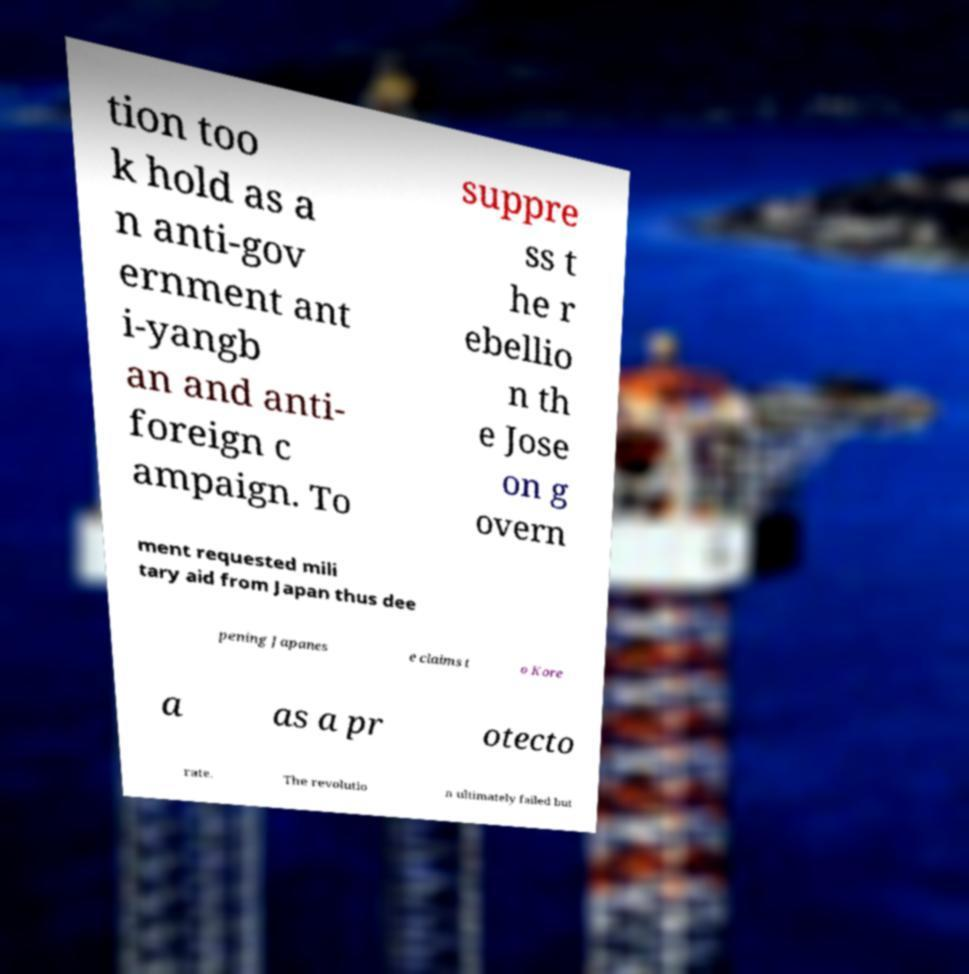Please identify and transcribe the text found in this image. tion too k hold as a n anti-gov ernment ant i-yangb an and anti- foreign c ampaign. To suppre ss t he r ebellio n th e Jose on g overn ment requested mili tary aid from Japan thus dee pening Japanes e claims t o Kore a as a pr otecto rate. The revolutio n ultimately failed but 